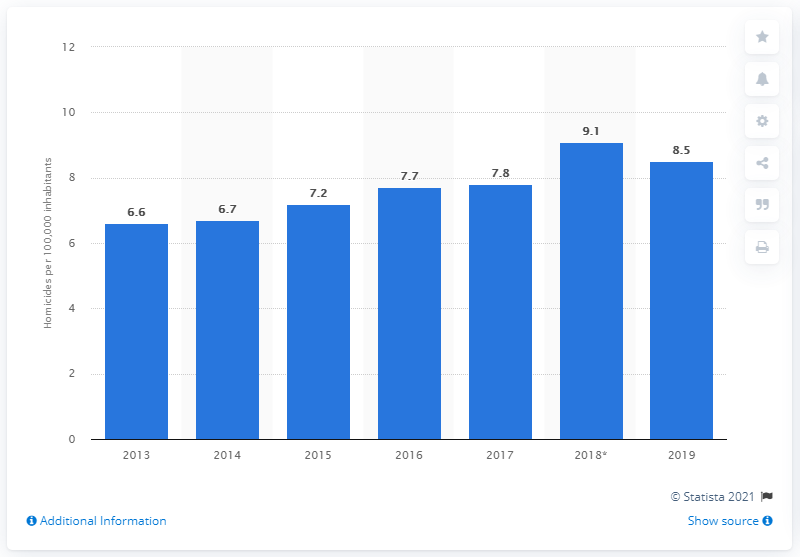Indicate a few pertinent items in this graphic. Since 2013, the homicide rate in Peru has been increasing. In 2018, the homicide rate was 9.1. In 2019, the homicide rate in Peru was 8.5 per 100,000 inhabitants. 